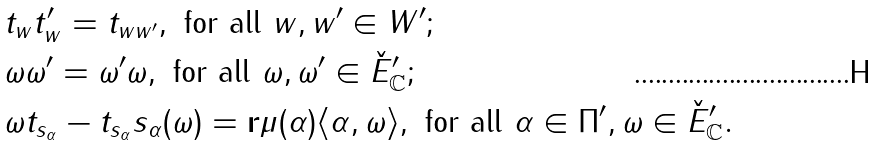Convert formula to latex. <formula><loc_0><loc_0><loc_500><loc_500>& t _ { w } t _ { w } ^ { \prime } = t _ { w w ^ { \prime } } , \text { for all } w , w ^ { \prime } \in W ^ { \prime } ; \\ & \omega \omega ^ { \prime } = \omega ^ { \prime } \omega , \text { for all } \omega , \omega ^ { \prime } \in \check { E } ^ { \prime } _ { \mathbb { C } } ; \\ & { \omega t _ { s _ { \alpha } } - t _ { s _ { \alpha } } s _ { \alpha } ( \omega ) = \mathbf r \mu ( \alpha ) \langle \alpha , \omega \rangle , \text { for all } \alpha \in \Pi ^ { \prime } , \omega \in \check { E } ^ { \prime } _ { \mathbb { C } } } .</formula> 